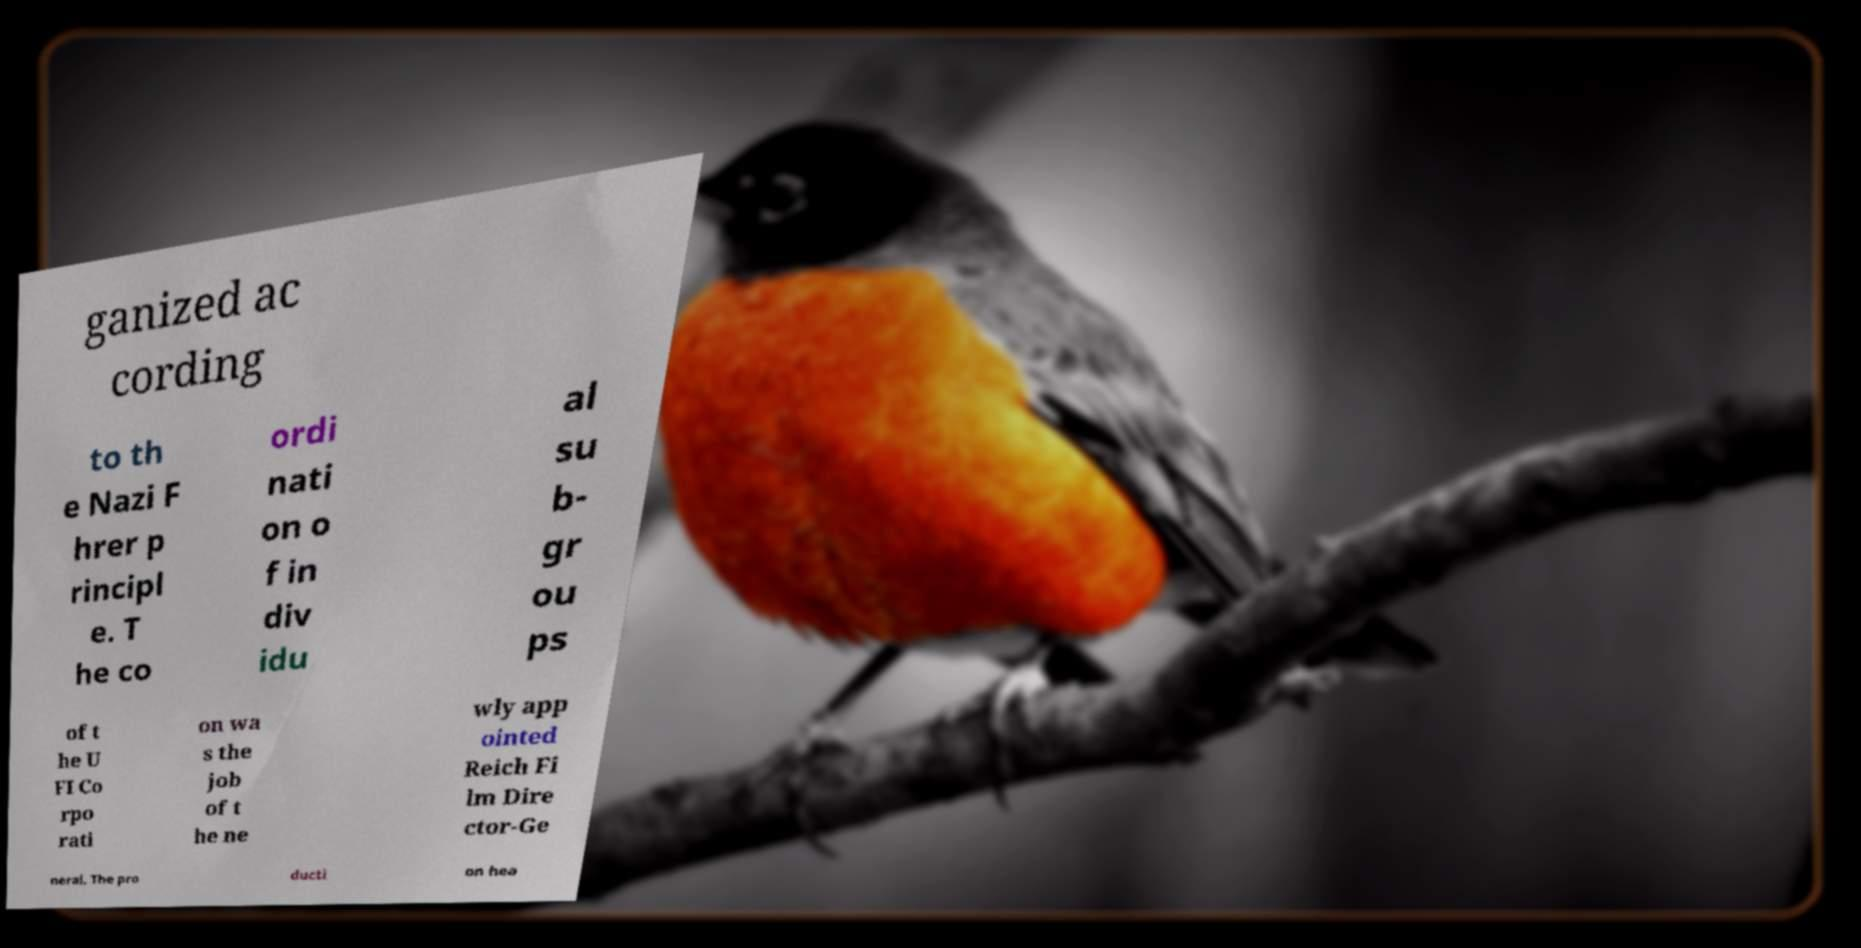Could you assist in decoding the text presented in this image and type it out clearly? ganized ac cording to th e Nazi F hrer p rincipl e. T he co ordi nati on o f in div idu al su b- gr ou ps of t he U FI Co rpo rati on wa s the job of t he ne wly app ointed Reich Fi lm Dire ctor-Ge neral. The pro ducti on hea 